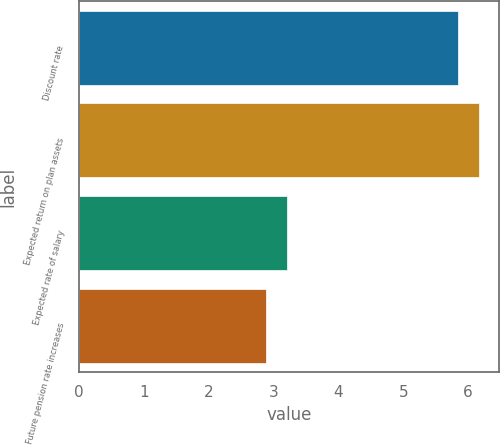<chart> <loc_0><loc_0><loc_500><loc_500><bar_chart><fcel>Discount rate<fcel>Expected return on plan assets<fcel>Expected rate of salary<fcel>Future pension rate increases<nl><fcel>5.84<fcel>6.17<fcel>3.21<fcel>2.88<nl></chart> 